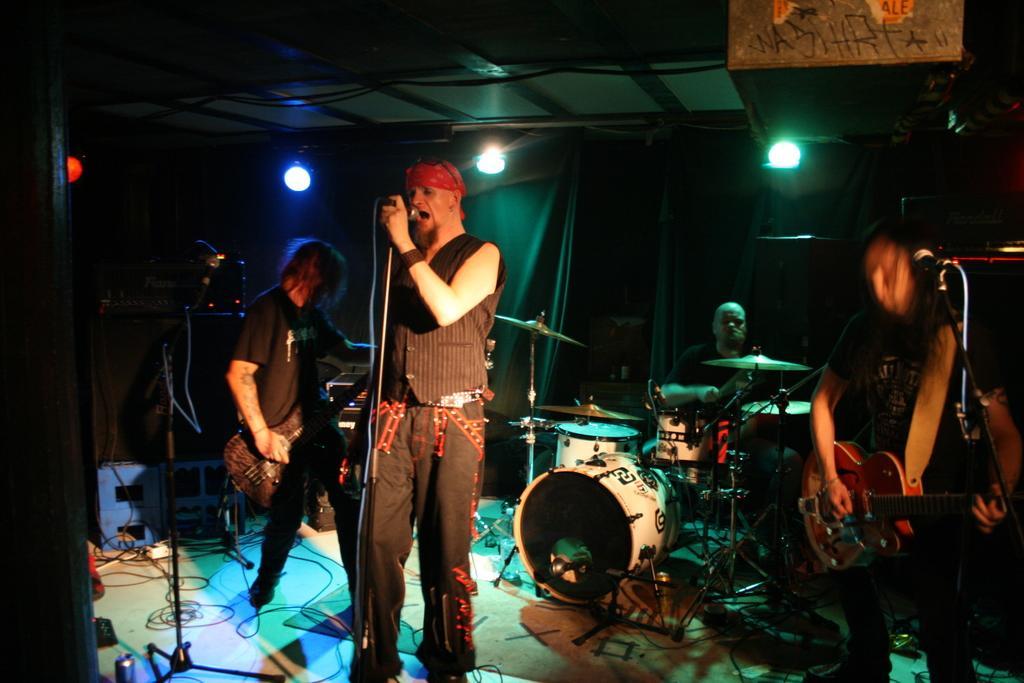Please provide a concise description of this image. On the background of the picture we can see curtains and lights. this is a ceiling. Here we can see three persons standing. These two are playing guitars and the man in the middle is singing in front of a mike. We can see one man sitting and playing drums. 